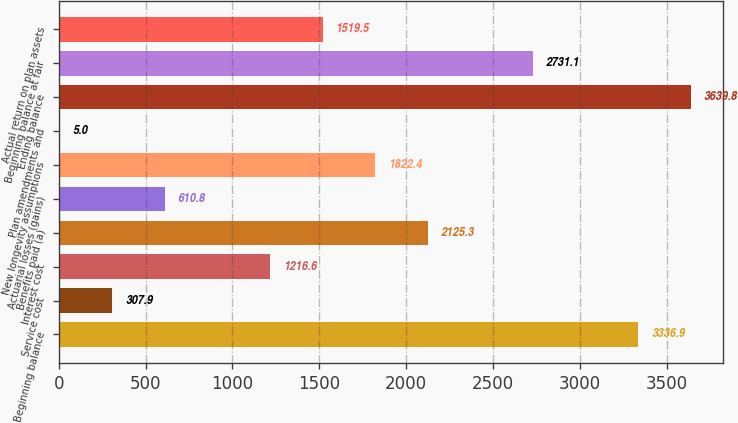Convert chart. <chart><loc_0><loc_0><loc_500><loc_500><bar_chart><fcel>Beginning balance<fcel>Service cost<fcel>Interest cost<fcel>Benefits paid (a)<fcel>Actuarial losses (gains)<fcel>New longevity assumptions<fcel>Plan amendments and<fcel>Ending balance<fcel>Beginning balance at fair<fcel>Actual return on plan assets<nl><fcel>3336.9<fcel>307.9<fcel>1216.6<fcel>2125.3<fcel>610.8<fcel>1822.4<fcel>5<fcel>3639.8<fcel>2731.1<fcel>1519.5<nl></chart> 